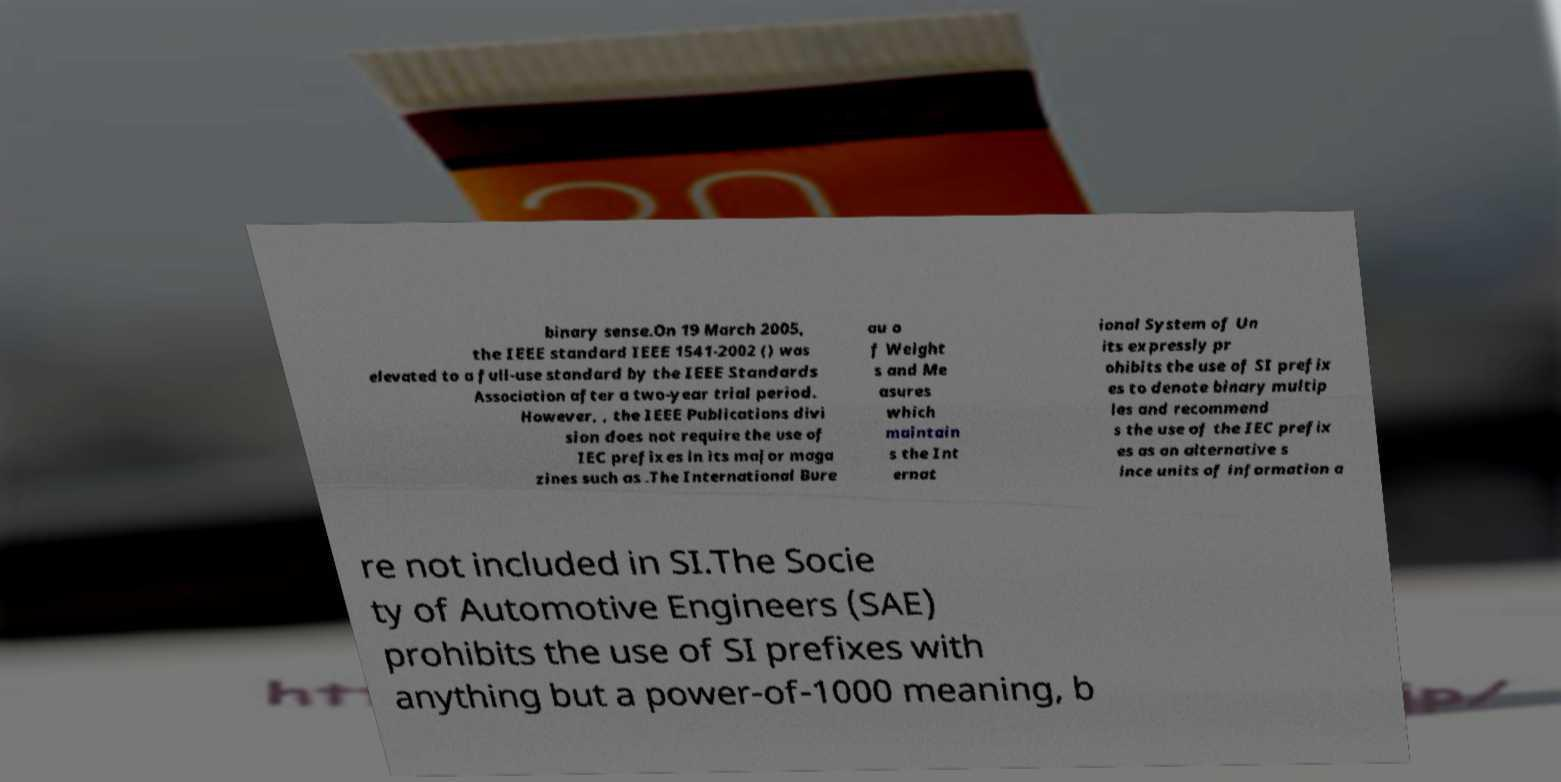Please read and relay the text visible in this image. What does it say? binary sense.On 19 March 2005, the IEEE standard IEEE 1541-2002 () was elevated to a full-use standard by the IEEE Standards Association after a two-year trial period. However, , the IEEE Publications divi sion does not require the use of IEC prefixes in its major maga zines such as .The International Bure au o f Weight s and Me asures which maintain s the Int ernat ional System of Un its expressly pr ohibits the use of SI prefix es to denote binary multip les and recommend s the use of the IEC prefix es as an alternative s ince units of information a re not included in SI.The Socie ty of Automotive Engineers (SAE) prohibits the use of SI prefixes with anything but a power-of-1000 meaning, b 